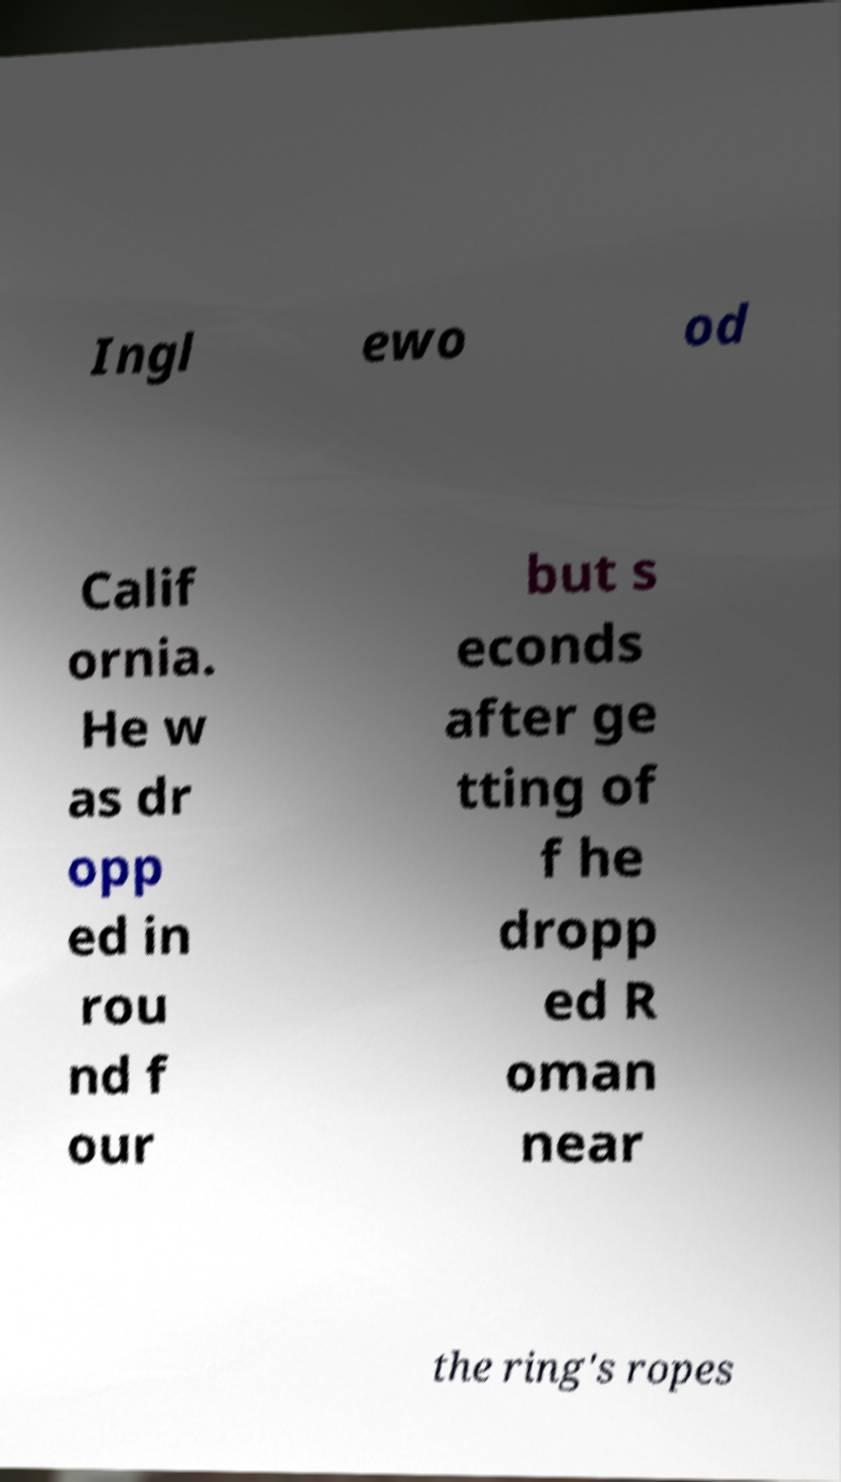What messages or text are displayed in this image? I need them in a readable, typed format. Ingl ewo od Calif ornia. He w as dr opp ed in rou nd f our but s econds after ge tting of f he dropp ed R oman near the ring's ropes 